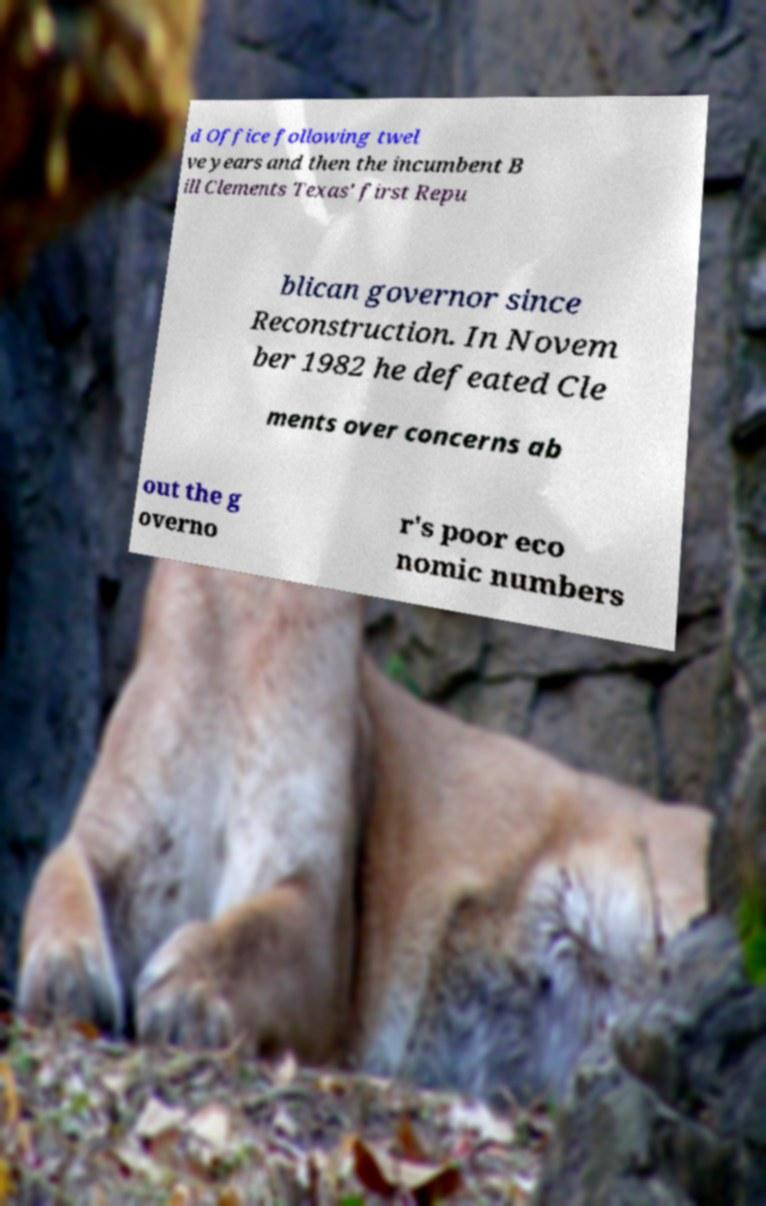Can you accurately transcribe the text from the provided image for me? d Office following twel ve years and then the incumbent B ill Clements Texas' first Repu blican governor since Reconstruction. In Novem ber 1982 he defeated Cle ments over concerns ab out the g overno r's poor eco nomic numbers 